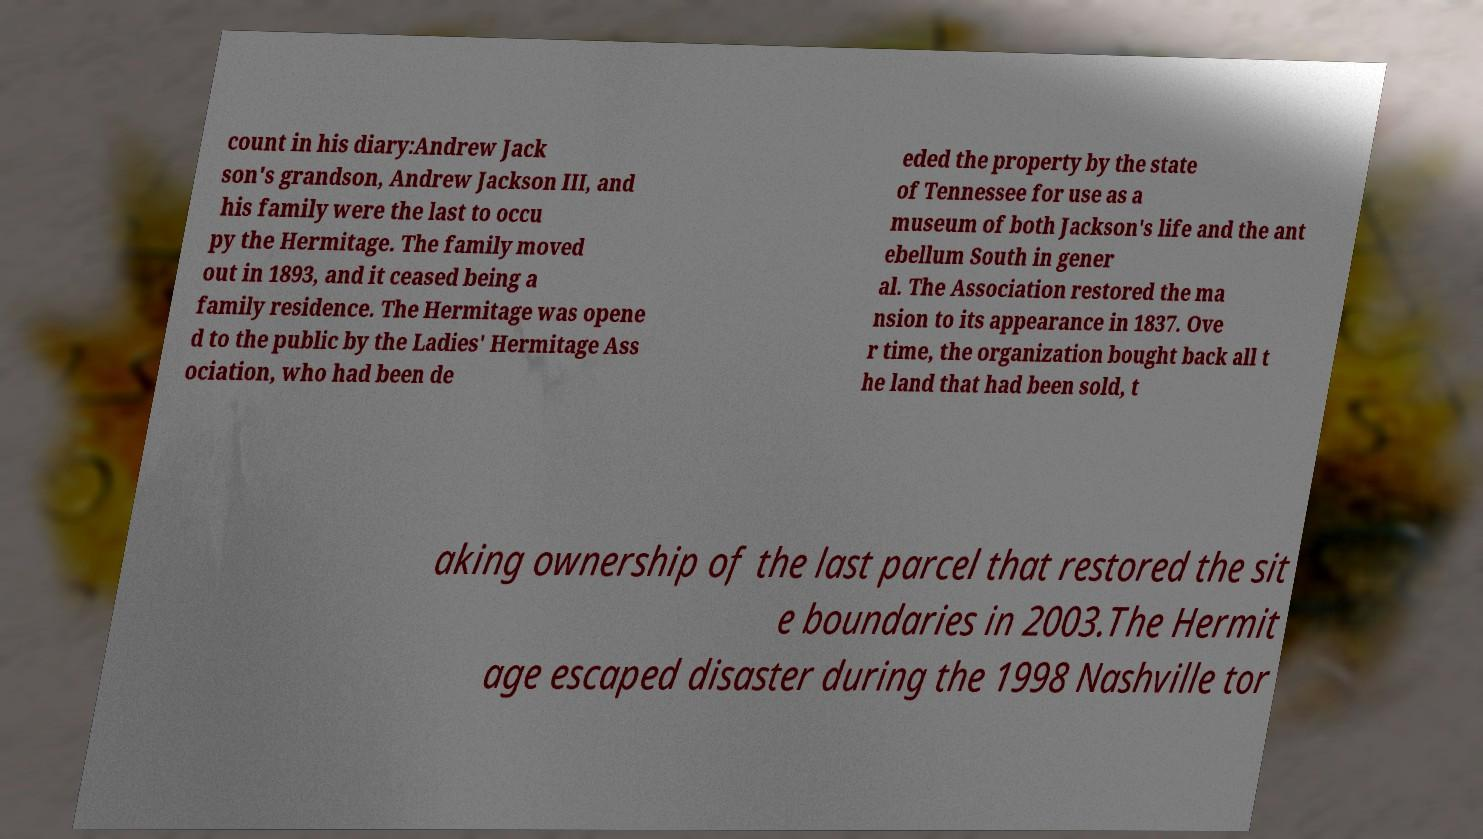Can you accurately transcribe the text from the provided image for me? count in his diary:Andrew Jack son's grandson, Andrew Jackson III, and his family were the last to occu py the Hermitage. The family moved out in 1893, and it ceased being a family residence. The Hermitage was opene d to the public by the Ladies' Hermitage Ass ociation, who had been de eded the property by the state of Tennessee for use as a museum of both Jackson's life and the ant ebellum South in gener al. The Association restored the ma nsion to its appearance in 1837. Ove r time, the organization bought back all t he land that had been sold, t aking ownership of the last parcel that restored the sit e boundaries in 2003.The Hermit age escaped disaster during the 1998 Nashville tor 